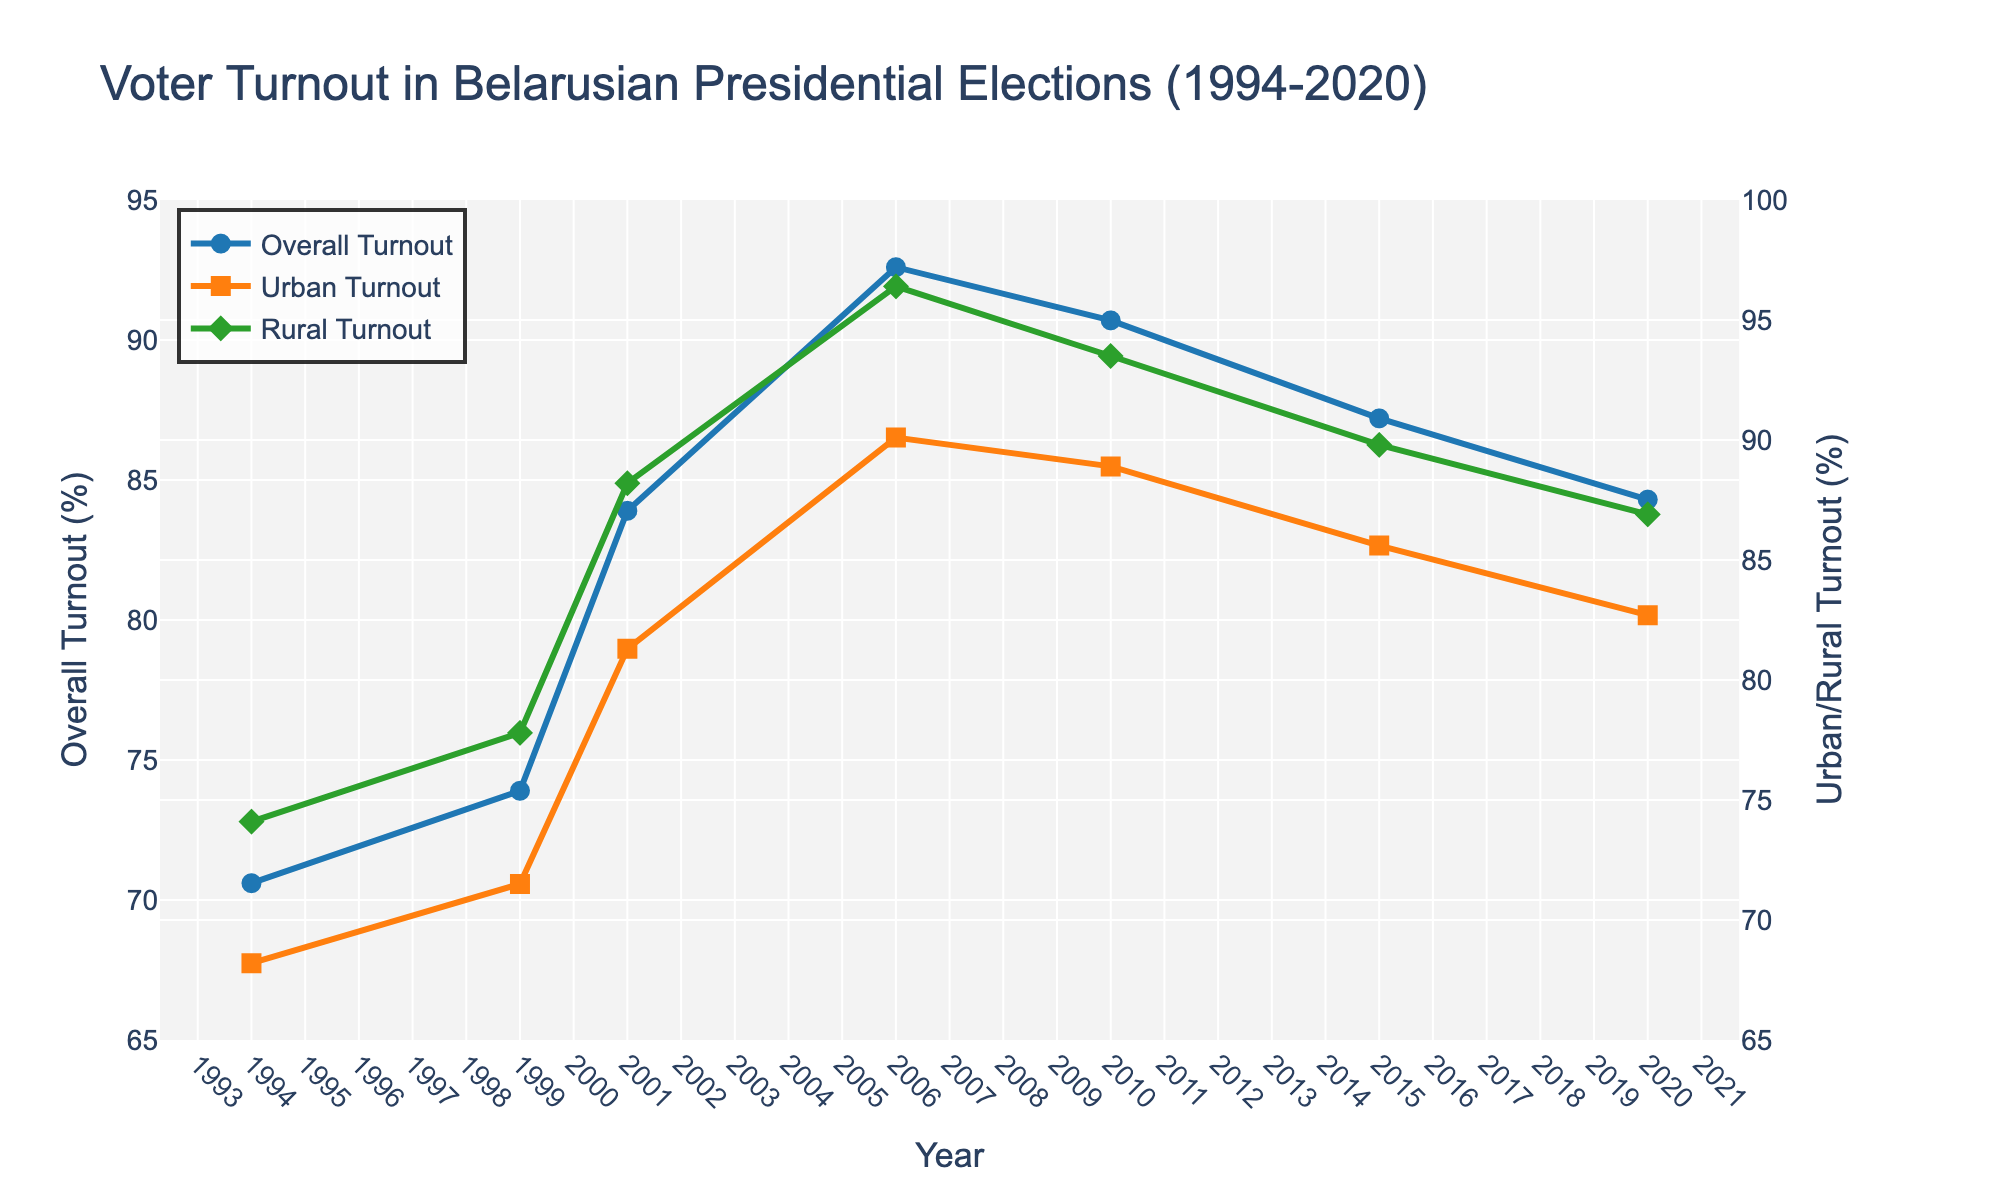How does the overall voter turnout trend from 1994 to 2020? The overall voter turnout generally increases from 70.6% in 1994 to a peak of 92.6% in 2006, then slightly decreases, reaching 84.3% in 2020.
Answer: It increases and then decreases Compare the urban and rural turnout in the 2006 election. The urban turnout in 2006 is 90.1%, while the rural turnout is 96.4%.
Answer: Rural turnout is higher Which year shows the smallest gap between urban and rural turnout? To find the smallest gap, we subtract the urban turnout from the rural turnout for each year: 
1994: 74.1 - 68.2 = 5.9 
1999: 77.8 - 71.5 = 6.3 
2001: 88.2 - 81.3 = 6.9 
2006: 96.4 - 90.1 = 6.3 
2010: 93.5 - 88.9 = 4.6 
2015: 89.8 - 85.6 = 4.2 
2020: 86.9 - 82.7 = 4.2 
The smallest gaps occur in 2015 and 2020 with a difference of 4.2%.
Answer: 2015 and 2020 Identify the year with the highest overall turnout. The highest overall turnout is in 2006, with 92.6%.
Answer: 2006 Calculate the average rural turnout from 1994 to 2020. Sum the rural turnout for all the years and then divide by the number of years: (74.1 + 77.8 + 88.2 + 96.4 + 93.5 + 89.8 + 86.9) / 7 = 606.7 / 7 = 86.67.
Answer: 86.67% Compare the trend of urban turnout with overall turnout from 2010 to 2020. Both urban and overall turnout show a decreasing trend from 2010 to 2020. The urban turnout decreases from 88.9% in 2010 to 82.7% in 2020, while overall turnout decreases from 90.7% in 2010 to 84.3% in 2020.
Answer: Both decrease What is the difference in rural turnout between the elections of 1994 and 2020? The rural turnout in 1994 is 74.1% and in 2020 is 86.9%. The difference is 86.9 - 74.1 = 12.8.
Answer: 12.8 Was there any year when the urban turnout was higher than the overall turnout? For each year, compare urban turnout with overall turnout:
1994: 68.2 < 70.6
1999: 71.5 < 73.9
2001: 81.3 < 83.9
2006: 90.1 < 92.6
2010: 88.9 < 90.7
2015: 85.6 < 87.2
2020: 82.7 < 84.3
The urban turnout was never higher than the overall turnout.
Answer: No How does the rural turnout in 2001 compare to the urban turnout? In 2001, the rural turnout is 88.2%, while the urban turnout is 81.3%.
Answer: Rural turnout is higher 